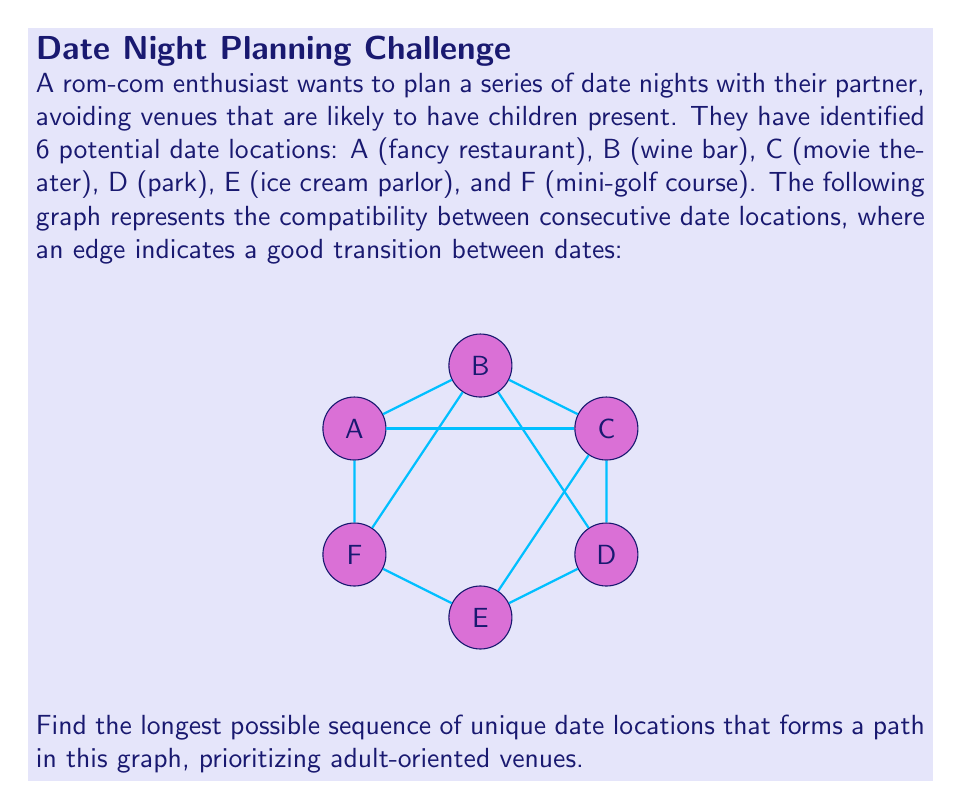What is the answer to this math problem? To solve this problem, we'll use a depth-first search (DFS) approach to find the longest path in the graph. We'll prioritize adult-oriented venues by starting our search from nodes A, B, and C, which represent locations less likely to have children present.

Step 1: Identify the adjacency list for each node:
A: B, C, F
B: A, C, D, F 
C: A, B, D, E
D: B, C, E
E: C, D, F
F: A, B, E

Step 2: Implement DFS from each starting node (A, B, C):

Starting from A:
1. A → B → C → D → E → F (length 6)
2. A → B → C → E → F (length 5)
3. A → B → D → C → E → F (length 6)
4. A → B → F → E → D → C (length 6)
5. A → C → B → D → E → F (length 6)
6. A → C → E → F (length 4)
7. A → F → E → C → B → D (length 6)

Starting from B:
1. B → A → C → D → E → F (length 6)
2. B → C → A → F → E → D (length 6)
3. B → D → C → A → F → E (length 6)
4. B → F → A → C → D → E (length 6)

Starting from C:
1. C → A → B → D → E → F (length 6)
2. C → B → A → F → E → D (length 6)
3. C → D → B → A → F → E (length 6)
4. C → E → F → A → B → D (length 6)

Step 3: Analyze the results:
We can see that there are multiple paths of length 6, which is the maximum possible length given that there are 6 unique locations. All of these paths visit each location exactly once.

Step 4: Choose the best path:
Since we want to prioritize adult-oriented venues, we should choose a path that starts with A (fancy restaurant), B (wine bar), or C (movie theater). Any of these paths would be equally suitable:

1. A → B → C → D → E → F
2. B → A → C → D → E → F
3. C → A → B → D → E → F

We'll select the first option as our answer, as it starts with the fancy restaurant, which is likely the most romantic and adult-oriented venue.
Answer: A → B → C → D → E → F 